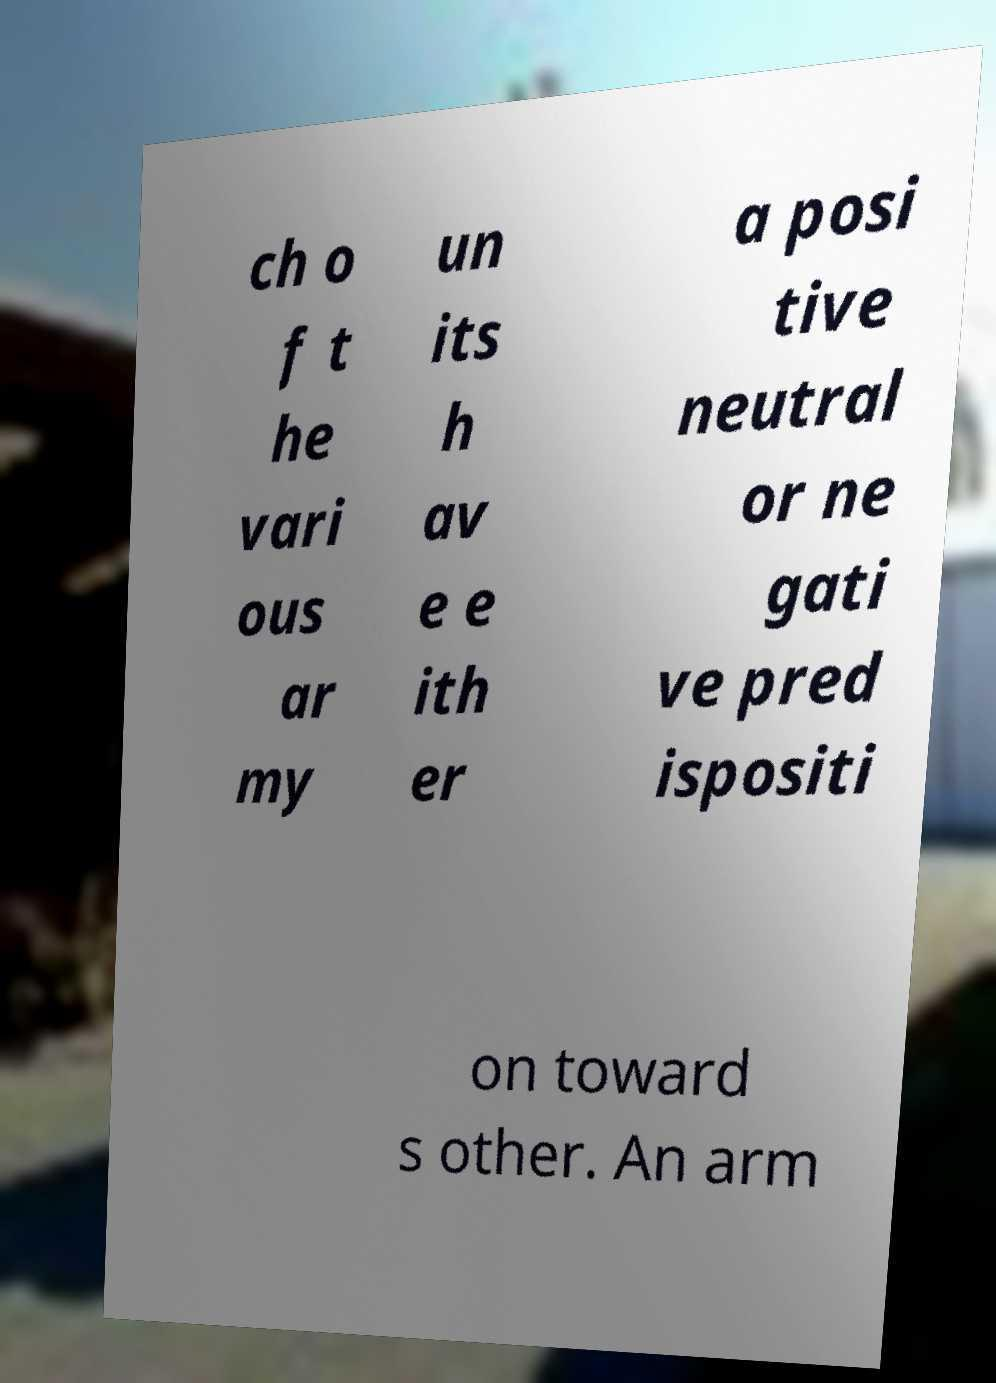Could you extract and type out the text from this image? ch o f t he vari ous ar my un its h av e e ith er a posi tive neutral or ne gati ve pred ispositi on toward s other. An arm 